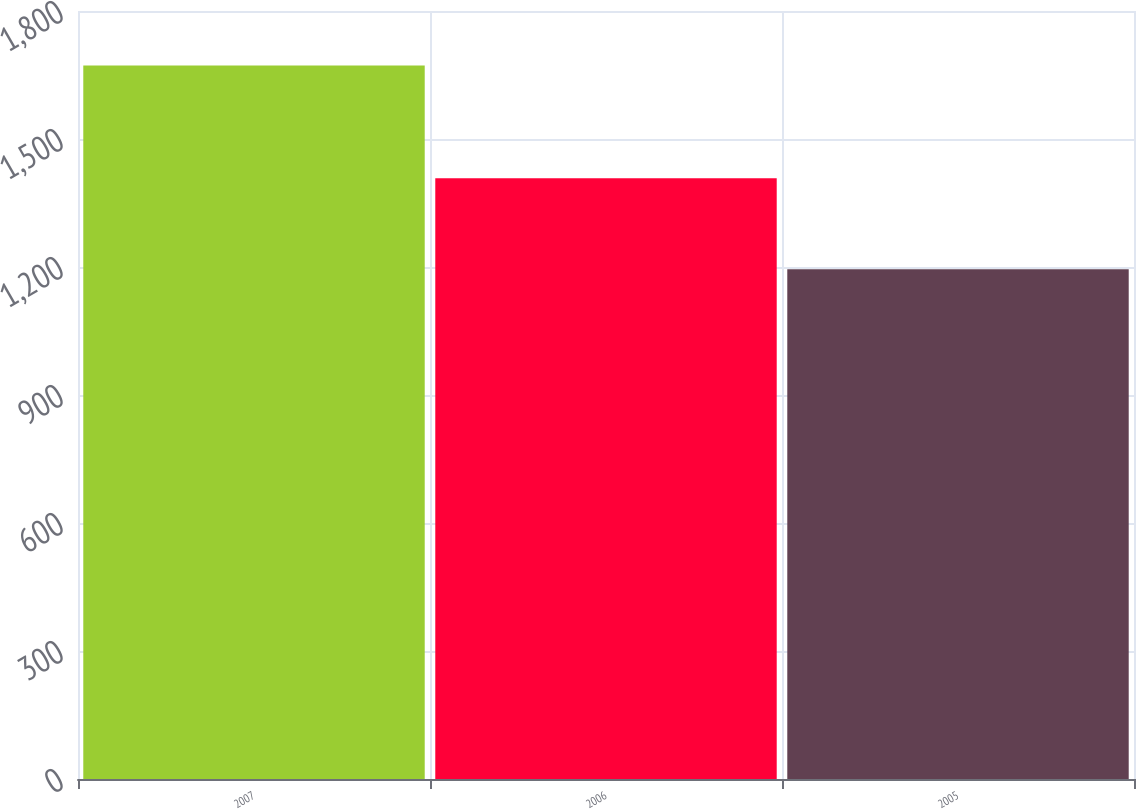<chart> <loc_0><loc_0><loc_500><loc_500><bar_chart><fcel>2007<fcel>2006<fcel>2005<nl><fcel>1672<fcel>1408<fcel>1195<nl></chart> 